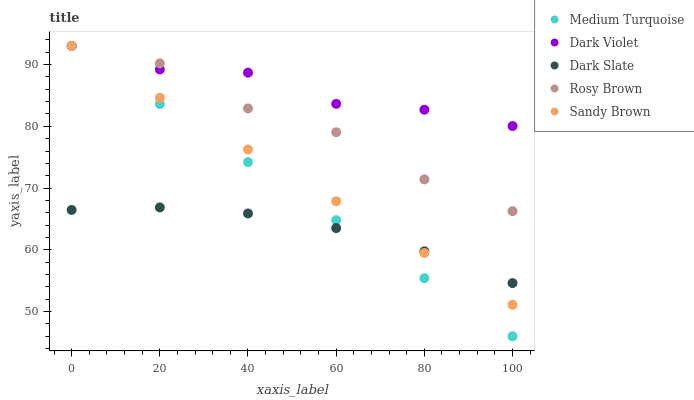Does Dark Slate have the minimum area under the curve?
Answer yes or no. Yes. Does Dark Violet have the maximum area under the curve?
Answer yes or no. Yes. Does Rosy Brown have the minimum area under the curve?
Answer yes or no. No. Does Rosy Brown have the maximum area under the curve?
Answer yes or no. No. Is Medium Turquoise the smoothest?
Answer yes or no. Yes. Is Rosy Brown the roughest?
Answer yes or no. Yes. Is Sandy Brown the smoothest?
Answer yes or no. No. Is Sandy Brown the roughest?
Answer yes or no. No. Does Medium Turquoise have the lowest value?
Answer yes or no. Yes. Does Rosy Brown have the lowest value?
Answer yes or no. No. Does Medium Turquoise have the highest value?
Answer yes or no. Yes. Is Dark Slate less than Dark Violet?
Answer yes or no. Yes. Is Dark Violet greater than Dark Slate?
Answer yes or no. Yes. Does Sandy Brown intersect Rosy Brown?
Answer yes or no. Yes. Is Sandy Brown less than Rosy Brown?
Answer yes or no. No. Is Sandy Brown greater than Rosy Brown?
Answer yes or no. No. Does Dark Slate intersect Dark Violet?
Answer yes or no. No. 